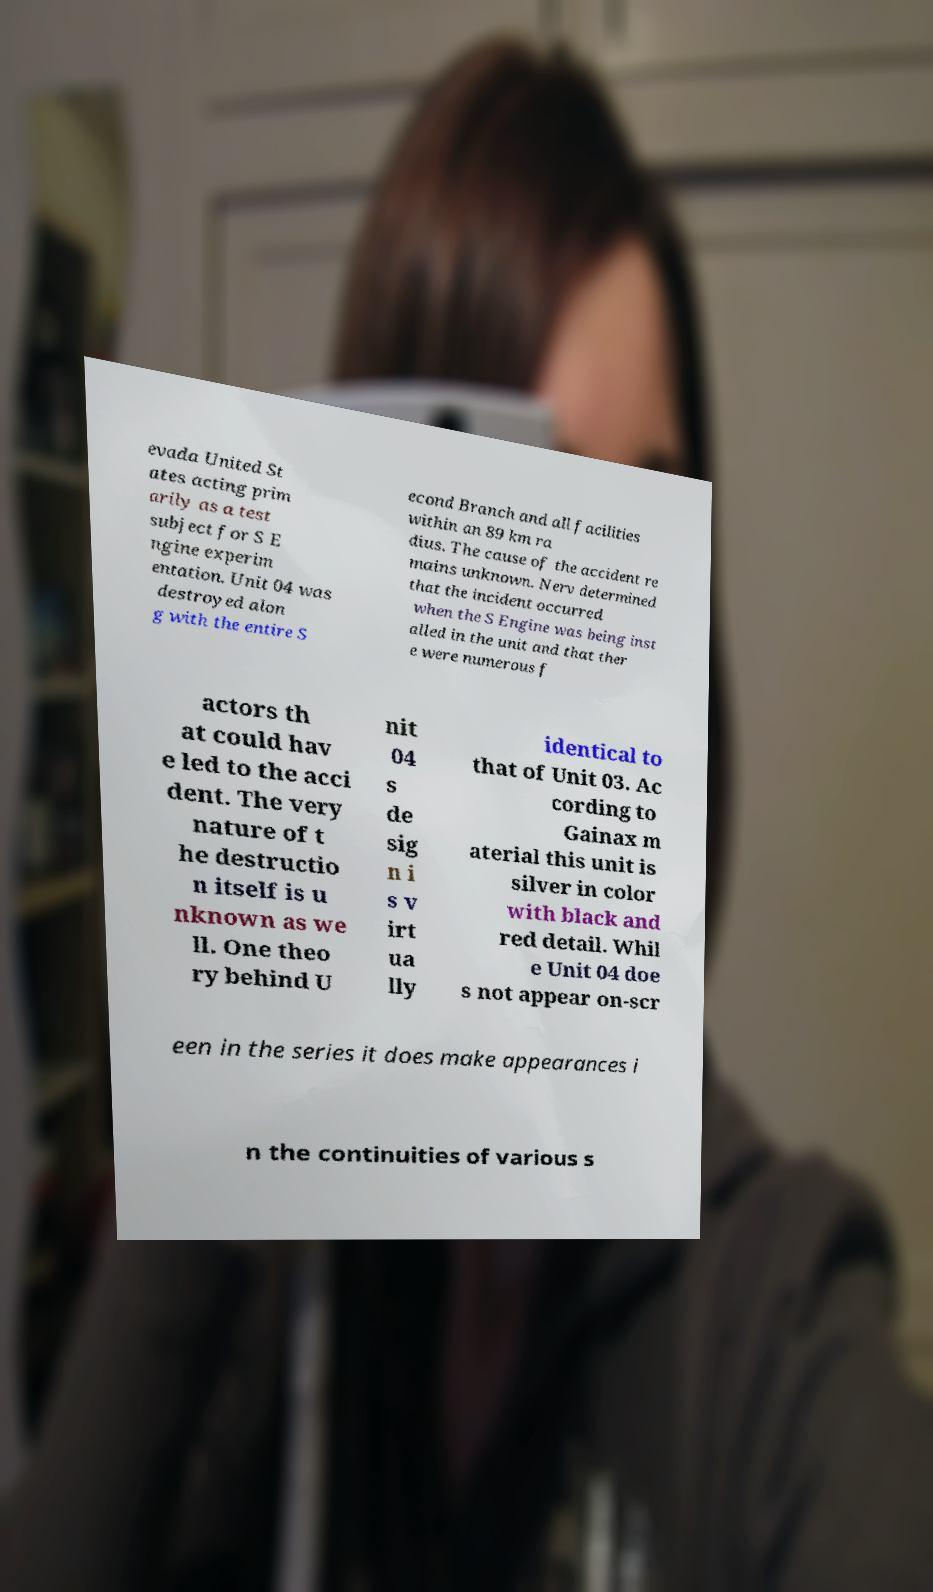There's text embedded in this image that I need extracted. Can you transcribe it verbatim? evada United St ates acting prim arily as a test subject for S E ngine experim entation. Unit 04 was destroyed alon g with the entire S econd Branch and all facilities within an 89 km ra dius. The cause of the accident re mains unknown. Nerv determined that the incident occurred when the S Engine was being inst alled in the unit and that ther e were numerous f actors th at could hav e led to the acci dent. The very nature of t he destructio n itself is u nknown as we ll. One theo ry behind U nit 04 s de sig n i s v irt ua lly identical to that of Unit 03. Ac cording to Gainax m aterial this unit is silver in color with black and red detail. Whil e Unit 04 doe s not appear on-scr een in the series it does make appearances i n the continuities of various s 